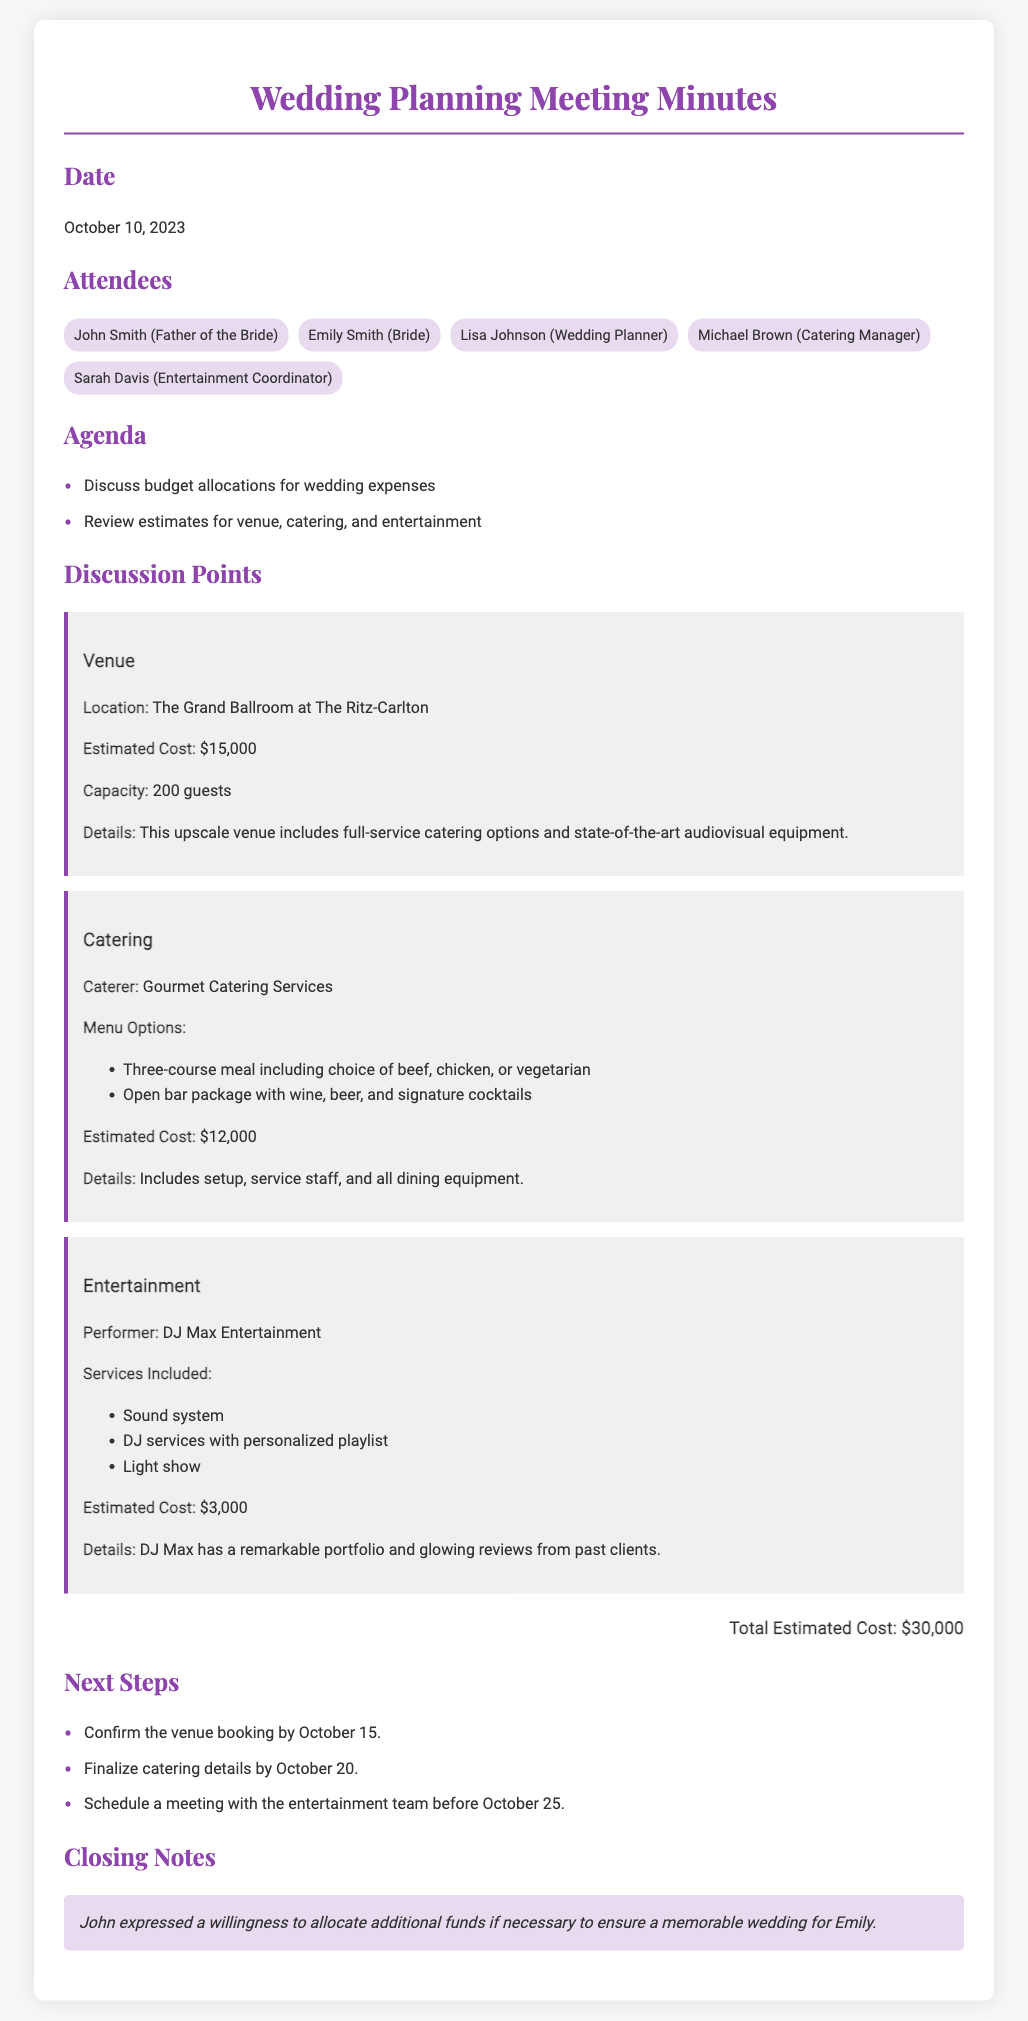What is the date of the meeting? The date of the meeting is mentioned in the document under the Date section, which is October 10, 2023.
Answer: October 10, 2023 Who is the catering manager? The name of the catering manager is listed among the attendees of the meeting.
Answer: Michael Brown What is the estimated cost for the venue? The estimated cost for the venue is specifically noted in the discussion points section.
Answer: $15,000 What is the total estimated cost for the wedding? The total estimated cost is summarized at the end of the discussion points regarding the budget allocations.
Answer: $30,000 When is the venue booking supposed to be confirmed? The deadline to confirm the venue booking is outlined in the next steps section of the document.
Answer: October 15 Which entertainment service has been chosen? The performer selected for the entertainment is specified under the discussion points about entertainment.
Answer: DJ Max Entertainment Which menu options are available from the caterer? The menu options provided by the caterer are listed in the discussion points regarding catering.
Answer: Three-course meal including choice of beef, chicken, or vegetarian What is John’s stance on the budget for the wedding? John’s perspective on budget allocations is stated in the closing notes of the document.
Answer: Willing to allocate additional funds 